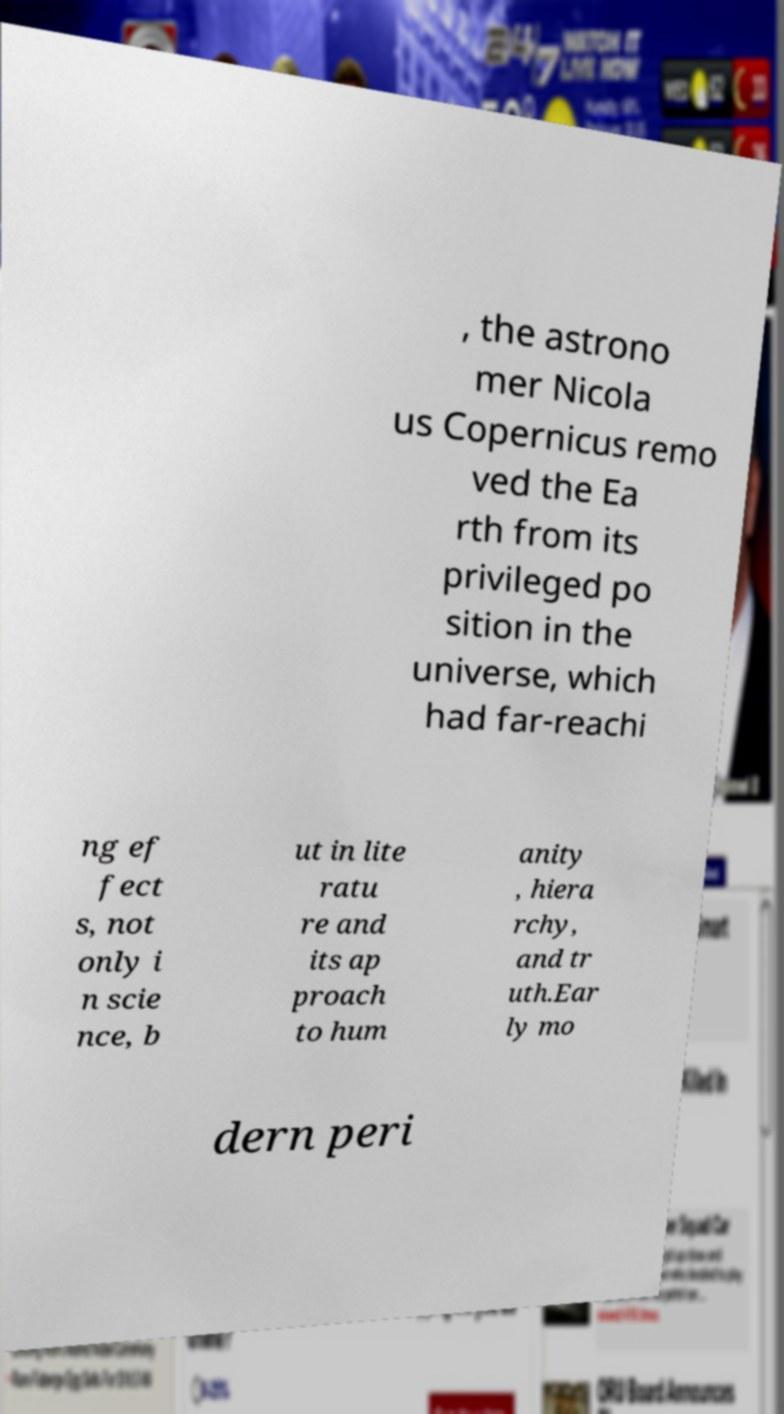For documentation purposes, I need the text within this image transcribed. Could you provide that? , the astrono mer Nicola us Copernicus remo ved the Ea rth from its privileged po sition in the universe, which had far-reachi ng ef fect s, not only i n scie nce, b ut in lite ratu re and its ap proach to hum anity , hiera rchy, and tr uth.Ear ly mo dern peri 